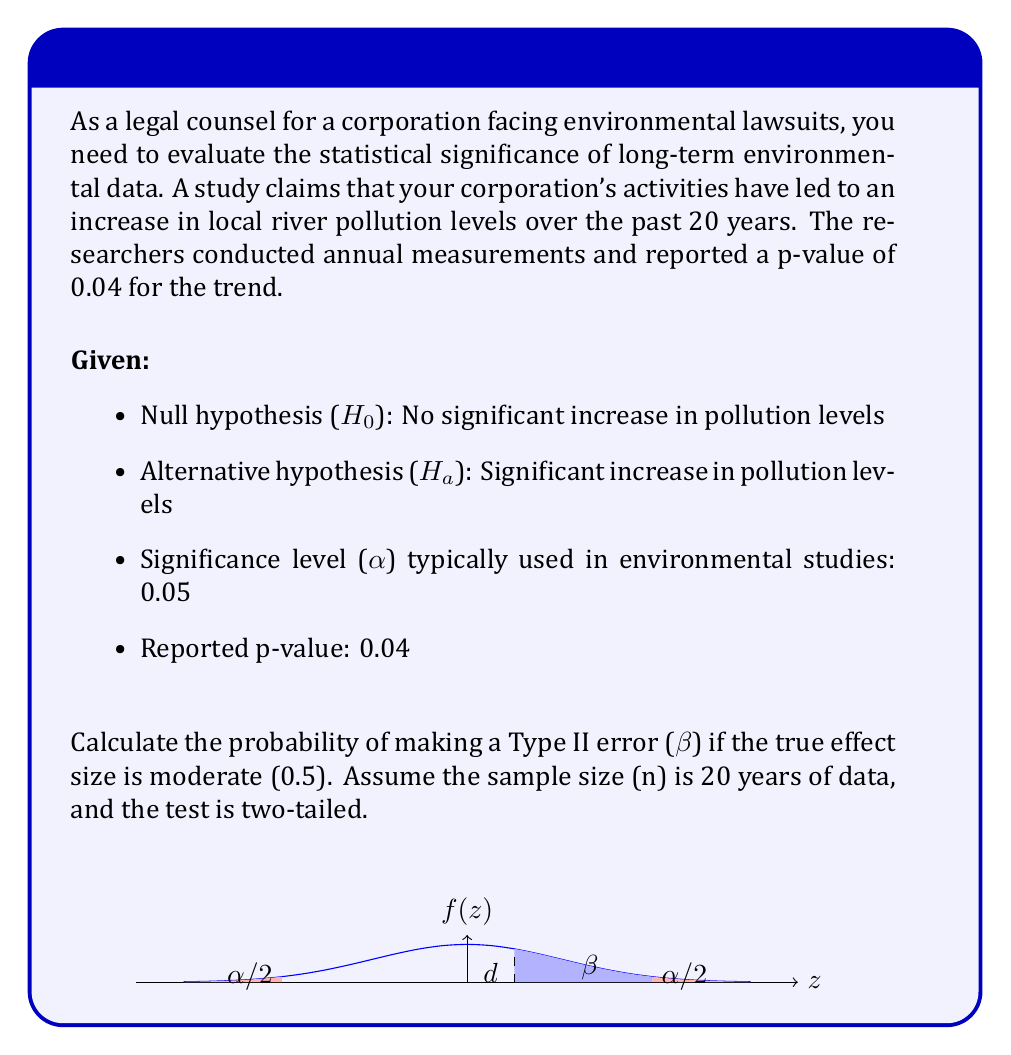Show me your answer to this math problem. To calculate the probability of a Type II error ($\beta$), we need to follow these steps:

1) First, we need to calculate the critical z-score for a two-tailed test at $\alpha = 0.05$:
   $z_{\alpha/2} = 1.96$ (from standard normal distribution table)

2) Calculate the standard error (SE) for the effect size:
   $SE = \frac{1}{\sqrt{n}} = \frac{1}{\sqrt{20}} = 0.2236$

3) Calculate the non-centrality parameter ($\delta$):
   $\delta = \frac{\text{effect size}}{SE} = \frac{0.5}{0.2236} = 2.236$

4) Calculate $\beta$ using the non-central t-distribution:
   $\beta = T(\text{df} = n-1, \text{ncp} = \delta, q = z_{\alpha/2}) - T(\text{df} = n-1, \text{ncp} = \delta, q = -z_{\alpha/2})$
   
   Where T is the cumulative distribution function of the non-central t-distribution.

5) Using statistical software or appropriate tables:
   $\beta \approx 0.2458$

6) Therefore, the probability of making a Type II error is approximately 0.2458 or 24.58%.

This result suggests that if there is indeed a moderate effect (0.5) of the corporation's activities on river pollution levels, there is about a 24.58% chance of failing to detect this effect given the current study design and sample size.
Answer: $\beta \approx 0.2458$ 